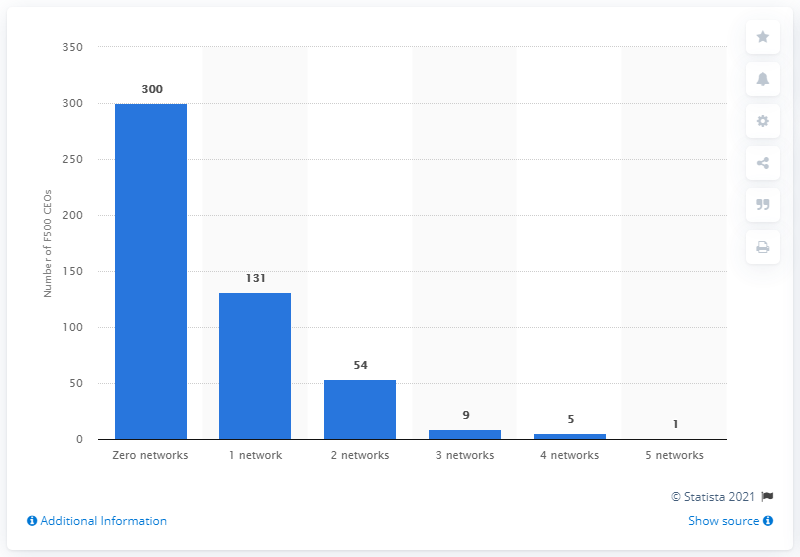Can you provide the total number of CEOs mentioned in the chart? The total number of CEOs mentioned in the chart is 500, which is the sum of CEOs across all categories ranging from zero to five social networks. 